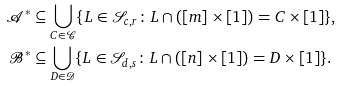<formula> <loc_0><loc_0><loc_500><loc_500>\mathcal { A } ^ { * } & \subseteq \bigcup _ { C \in \mathcal { C } } \{ L \in \mathcal { S } _ { { c } , r } \colon L \cap ( [ m ] \times [ 1 ] ) = C \times [ 1 ] \} , \\ \mathcal { B } ^ { * } & \subseteq \bigcup _ { D \in \mathcal { D } } \{ L \in \mathcal { S } _ { { d } , s } \colon L \cap ( [ n ] \times [ 1 ] ) = D \times [ 1 ] \} .</formula> 